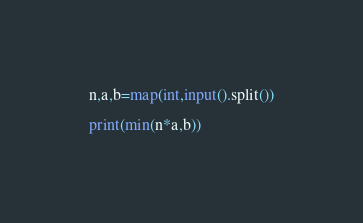<code> <loc_0><loc_0><loc_500><loc_500><_Python_>
n,a,b=map(int,input().split())

print(min(n*a,b))


</code> 